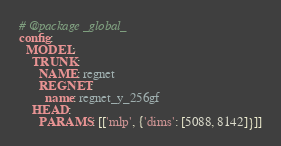<code> <loc_0><loc_0><loc_500><loc_500><_YAML_># @package _global_
config:
  MODEL:
    TRUNK:
      NAME: regnet
      REGNET:
        name: regnet_y_256gf
    HEAD:
      PARAMS: [['mlp', {'dims': [5088, 8142]}]]
</code> 